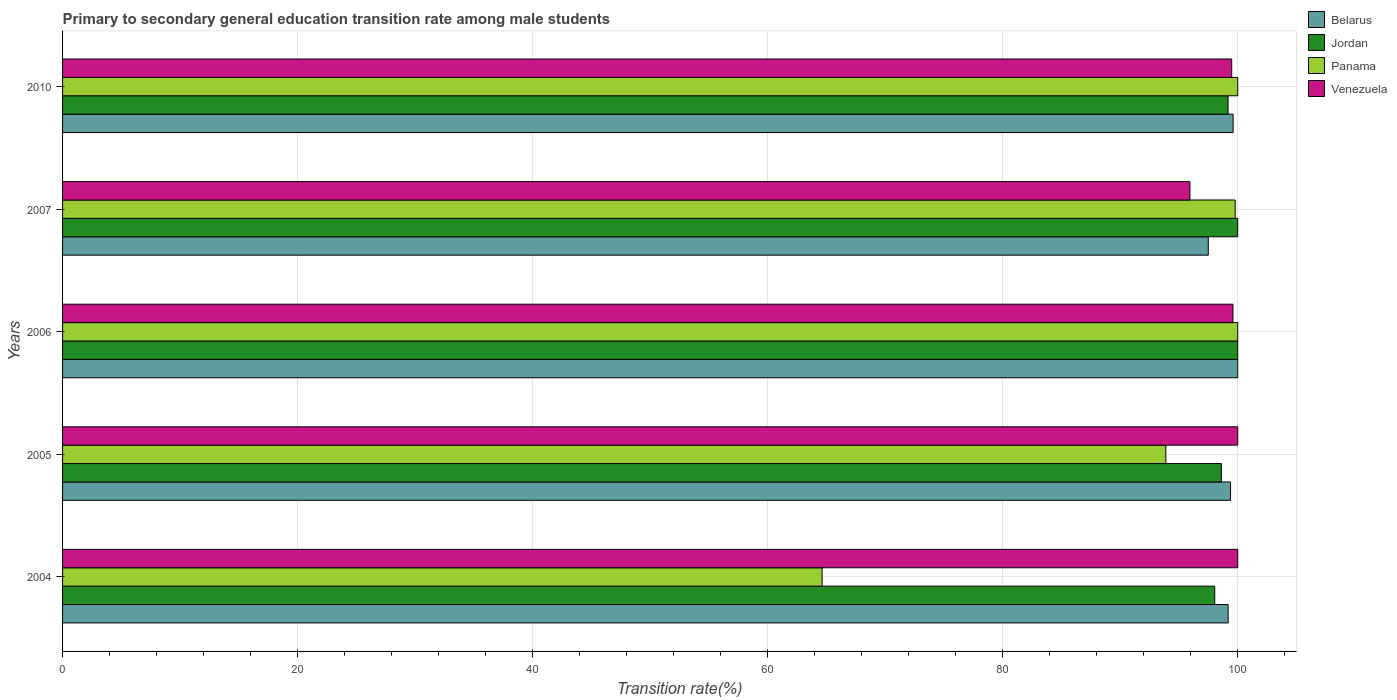How many different coloured bars are there?
Your response must be concise. 4. Are the number of bars per tick equal to the number of legend labels?
Your answer should be very brief. Yes. How many bars are there on the 3rd tick from the bottom?
Provide a short and direct response. 4. What is the label of the 4th group of bars from the top?
Provide a succinct answer. 2005. In how many cases, is the number of bars for a given year not equal to the number of legend labels?
Your response must be concise. 0. What is the transition rate in Belarus in 2004?
Make the answer very short. 99.19. Across all years, what is the minimum transition rate in Jordan?
Make the answer very short. 98.04. In which year was the transition rate in Belarus minimum?
Ensure brevity in your answer.  2007. What is the total transition rate in Panama in the graph?
Offer a terse response. 458.3. What is the difference between the transition rate in Panama in 2004 and that in 2010?
Make the answer very short. -35.37. What is the difference between the transition rate in Jordan in 2004 and the transition rate in Panama in 2006?
Your answer should be very brief. -1.96. What is the average transition rate in Venezuela per year?
Give a very brief answer. 99. In the year 2007, what is the difference between the transition rate in Panama and transition rate in Belarus?
Make the answer very short. 2.29. What is the ratio of the transition rate in Jordan in 2004 to that in 2005?
Ensure brevity in your answer.  0.99. Is the difference between the transition rate in Panama in 2004 and 2006 greater than the difference between the transition rate in Belarus in 2004 and 2006?
Provide a short and direct response. No. What is the difference between the highest and the lowest transition rate in Venezuela?
Offer a terse response. 4.07. Is the sum of the transition rate in Jordan in 2006 and 2007 greater than the maximum transition rate in Panama across all years?
Give a very brief answer. Yes. What does the 4th bar from the top in 2006 represents?
Give a very brief answer. Belarus. What does the 1st bar from the bottom in 2007 represents?
Your answer should be very brief. Belarus. Is it the case that in every year, the sum of the transition rate in Jordan and transition rate in Panama is greater than the transition rate in Venezuela?
Give a very brief answer. Yes. How many bars are there?
Offer a terse response. 20. How many years are there in the graph?
Your answer should be very brief. 5. What is the difference between two consecutive major ticks on the X-axis?
Ensure brevity in your answer.  20. Does the graph contain any zero values?
Make the answer very short. No. How many legend labels are there?
Your answer should be very brief. 4. What is the title of the graph?
Offer a terse response. Primary to secondary general education transition rate among male students. What is the label or title of the X-axis?
Provide a short and direct response. Transition rate(%). What is the label or title of the Y-axis?
Keep it short and to the point. Years. What is the Transition rate(%) of Belarus in 2004?
Provide a short and direct response. 99.19. What is the Transition rate(%) of Jordan in 2004?
Make the answer very short. 98.04. What is the Transition rate(%) in Panama in 2004?
Provide a succinct answer. 64.63. What is the Transition rate(%) of Belarus in 2005?
Make the answer very short. 99.39. What is the Transition rate(%) of Jordan in 2005?
Your answer should be compact. 98.61. What is the Transition rate(%) of Panama in 2005?
Offer a very short reply. 93.88. What is the Transition rate(%) of Venezuela in 2006?
Offer a very short reply. 99.59. What is the Transition rate(%) in Belarus in 2007?
Your answer should be compact. 97.49. What is the Transition rate(%) in Panama in 2007?
Offer a very short reply. 99.79. What is the Transition rate(%) of Venezuela in 2007?
Provide a succinct answer. 95.93. What is the Transition rate(%) in Belarus in 2010?
Your response must be concise. 99.61. What is the Transition rate(%) in Jordan in 2010?
Make the answer very short. 99.18. What is the Transition rate(%) of Venezuela in 2010?
Provide a succinct answer. 99.49. Across all years, what is the maximum Transition rate(%) in Venezuela?
Ensure brevity in your answer.  100. Across all years, what is the minimum Transition rate(%) in Belarus?
Make the answer very short. 97.49. Across all years, what is the minimum Transition rate(%) of Jordan?
Offer a terse response. 98.04. Across all years, what is the minimum Transition rate(%) in Panama?
Ensure brevity in your answer.  64.63. Across all years, what is the minimum Transition rate(%) in Venezuela?
Ensure brevity in your answer.  95.93. What is the total Transition rate(%) in Belarus in the graph?
Keep it short and to the point. 495.68. What is the total Transition rate(%) of Jordan in the graph?
Your response must be concise. 495.83. What is the total Transition rate(%) in Panama in the graph?
Your response must be concise. 458.3. What is the total Transition rate(%) in Venezuela in the graph?
Your answer should be very brief. 495.01. What is the difference between the Transition rate(%) of Belarus in 2004 and that in 2005?
Provide a succinct answer. -0.2. What is the difference between the Transition rate(%) in Jordan in 2004 and that in 2005?
Ensure brevity in your answer.  -0.57. What is the difference between the Transition rate(%) in Panama in 2004 and that in 2005?
Ensure brevity in your answer.  -29.25. What is the difference between the Transition rate(%) in Venezuela in 2004 and that in 2005?
Provide a succinct answer. 0. What is the difference between the Transition rate(%) in Belarus in 2004 and that in 2006?
Your answer should be very brief. -0.81. What is the difference between the Transition rate(%) in Jordan in 2004 and that in 2006?
Your answer should be compact. -1.96. What is the difference between the Transition rate(%) in Panama in 2004 and that in 2006?
Keep it short and to the point. -35.37. What is the difference between the Transition rate(%) in Venezuela in 2004 and that in 2006?
Your answer should be compact. 0.41. What is the difference between the Transition rate(%) in Belarus in 2004 and that in 2007?
Give a very brief answer. 1.69. What is the difference between the Transition rate(%) in Jordan in 2004 and that in 2007?
Offer a terse response. -1.96. What is the difference between the Transition rate(%) in Panama in 2004 and that in 2007?
Give a very brief answer. -35.15. What is the difference between the Transition rate(%) in Venezuela in 2004 and that in 2007?
Keep it short and to the point. 4.07. What is the difference between the Transition rate(%) in Belarus in 2004 and that in 2010?
Offer a very short reply. -0.42. What is the difference between the Transition rate(%) in Jordan in 2004 and that in 2010?
Offer a terse response. -1.13. What is the difference between the Transition rate(%) of Panama in 2004 and that in 2010?
Your answer should be compact. -35.37. What is the difference between the Transition rate(%) of Venezuela in 2004 and that in 2010?
Ensure brevity in your answer.  0.51. What is the difference between the Transition rate(%) in Belarus in 2005 and that in 2006?
Offer a terse response. -0.61. What is the difference between the Transition rate(%) in Jordan in 2005 and that in 2006?
Your response must be concise. -1.39. What is the difference between the Transition rate(%) of Panama in 2005 and that in 2006?
Your response must be concise. -6.12. What is the difference between the Transition rate(%) of Venezuela in 2005 and that in 2006?
Your answer should be very brief. 0.41. What is the difference between the Transition rate(%) of Belarus in 2005 and that in 2007?
Provide a succinct answer. 1.9. What is the difference between the Transition rate(%) in Jordan in 2005 and that in 2007?
Offer a very short reply. -1.39. What is the difference between the Transition rate(%) in Panama in 2005 and that in 2007?
Provide a succinct answer. -5.91. What is the difference between the Transition rate(%) in Venezuela in 2005 and that in 2007?
Give a very brief answer. 4.07. What is the difference between the Transition rate(%) in Belarus in 2005 and that in 2010?
Provide a short and direct response. -0.22. What is the difference between the Transition rate(%) of Jordan in 2005 and that in 2010?
Ensure brevity in your answer.  -0.57. What is the difference between the Transition rate(%) of Panama in 2005 and that in 2010?
Your response must be concise. -6.12. What is the difference between the Transition rate(%) of Venezuela in 2005 and that in 2010?
Your answer should be compact. 0.51. What is the difference between the Transition rate(%) of Belarus in 2006 and that in 2007?
Make the answer very short. 2.51. What is the difference between the Transition rate(%) in Jordan in 2006 and that in 2007?
Provide a short and direct response. 0. What is the difference between the Transition rate(%) in Panama in 2006 and that in 2007?
Offer a very short reply. 0.21. What is the difference between the Transition rate(%) of Venezuela in 2006 and that in 2007?
Keep it short and to the point. 3.66. What is the difference between the Transition rate(%) of Belarus in 2006 and that in 2010?
Provide a succinct answer. 0.39. What is the difference between the Transition rate(%) of Jordan in 2006 and that in 2010?
Ensure brevity in your answer.  0.82. What is the difference between the Transition rate(%) in Panama in 2006 and that in 2010?
Your response must be concise. 0. What is the difference between the Transition rate(%) of Venezuela in 2006 and that in 2010?
Provide a succinct answer. 0.1. What is the difference between the Transition rate(%) in Belarus in 2007 and that in 2010?
Give a very brief answer. -2.11. What is the difference between the Transition rate(%) in Jordan in 2007 and that in 2010?
Provide a short and direct response. 0.82. What is the difference between the Transition rate(%) in Panama in 2007 and that in 2010?
Offer a very short reply. -0.21. What is the difference between the Transition rate(%) of Venezuela in 2007 and that in 2010?
Make the answer very short. -3.56. What is the difference between the Transition rate(%) in Belarus in 2004 and the Transition rate(%) in Jordan in 2005?
Offer a very short reply. 0.58. What is the difference between the Transition rate(%) of Belarus in 2004 and the Transition rate(%) of Panama in 2005?
Offer a terse response. 5.31. What is the difference between the Transition rate(%) of Belarus in 2004 and the Transition rate(%) of Venezuela in 2005?
Provide a short and direct response. -0.81. What is the difference between the Transition rate(%) in Jordan in 2004 and the Transition rate(%) in Panama in 2005?
Offer a very short reply. 4.16. What is the difference between the Transition rate(%) in Jordan in 2004 and the Transition rate(%) in Venezuela in 2005?
Make the answer very short. -1.96. What is the difference between the Transition rate(%) of Panama in 2004 and the Transition rate(%) of Venezuela in 2005?
Make the answer very short. -35.37. What is the difference between the Transition rate(%) in Belarus in 2004 and the Transition rate(%) in Jordan in 2006?
Keep it short and to the point. -0.81. What is the difference between the Transition rate(%) of Belarus in 2004 and the Transition rate(%) of Panama in 2006?
Provide a short and direct response. -0.81. What is the difference between the Transition rate(%) in Belarus in 2004 and the Transition rate(%) in Venezuela in 2006?
Offer a very short reply. -0.41. What is the difference between the Transition rate(%) of Jordan in 2004 and the Transition rate(%) of Panama in 2006?
Keep it short and to the point. -1.96. What is the difference between the Transition rate(%) of Jordan in 2004 and the Transition rate(%) of Venezuela in 2006?
Your answer should be very brief. -1.55. What is the difference between the Transition rate(%) of Panama in 2004 and the Transition rate(%) of Venezuela in 2006?
Give a very brief answer. -34.96. What is the difference between the Transition rate(%) in Belarus in 2004 and the Transition rate(%) in Jordan in 2007?
Your response must be concise. -0.81. What is the difference between the Transition rate(%) of Belarus in 2004 and the Transition rate(%) of Panama in 2007?
Provide a short and direct response. -0.6. What is the difference between the Transition rate(%) of Belarus in 2004 and the Transition rate(%) of Venezuela in 2007?
Your answer should be very brief. 3.25. What is the difference between the Transition rate(%) in Jordan in 2004 and the Transition rate(%) in Panama in 2007?
Ensure brevity in your answer.  -1.74. What is the difference between the Transition rate(%) in Jordan in 2004 and the Transition rate(%) in Venezuela in 2007?
Your answer should be very brief. 2.11. What is the difference between the Transition rate(%) in Panama in 2004 and the Transition rate(%) in Venezuela in 2007?
Make the answer very short. -31.3. What is the difference between the Transition rate(%) in Belarus in 2004 and the Transition rate(%) in Jordan in 2010?
Offer a very short reply. 0.01. What is the difference between the Transition rate(%) in Belarus in 2004 and the Transition rate(%) in Panama in 2010?
Give a very brief answer. -0.81. What is the difference between the Transition rate(%) of Belarus in 2004 and the Transition rate(%) of Venezuela in 2010?
Provide a succinct answer. -0.3. What is the difference between the Transition rate(%) in Jordan in 2004 and the Transition rate(%) in Panama in 2010?
Your answer should be very brief. -1.96. What is the difference between the Transition rate(%) in Jordan in 2004 and the Transition rate(%) in Venezuela in 2010?
Keep it short and to the point. -1.44. What is the difference between the Transition rate(%) of Panama in 2004 and the Transition rate(%) of Venezuela in 2010?
Your answer should be compact. -34.85. What is the difference between the Transition rate(%) in Belarus in 2005 and the Transition rate(%) in Jordan in 2006?
Your answer should be very brief. -0.61. What is the difference between the Transition rate(%) in Belarus in 2005 and the Transition rate(%) in Panama in 2006?
Keep it short and to the point. -0.61. What is the difference between the Transition rate(%) of Belarus in 2005 and the Transition rate(%) of Venezuela in 2006?
Provide a succinct answer. -0.2. What is the difference between the Transition rate(%) of Jordan in 2005 and the Transition rate(%) of Panama in 2006?
Keep it short and to the point. -1.39. What is the difference between the Transition rate(%) in Jordan in 2005 and the Transition rate(%) in Venezuela in 2006?
Ensure brevity in your answer.  -0.98. What is the difference between the Transition rate(%) of Panama in 2005 and the Transition rate(%) of Venezuela in 2006?
Make the answer very short. -5.71. What is the difference between the Transition rate(%) in Belarus in 2005 and the Transition rate(%) in Jordan in 2007?
Ensure brevity in your answer.  -0.61. What is the difference between the Transition rate(%) in Belarus in 2005 and the Transition rate(%) in Panama in 2007?
Offer a terse response. -0.4. What is the difference between the Transition rate(%) of Belarus in 2005 and the Transition rate(%) of Venezuela in 2007?
Make the answer very short. 3.46. What is the difference between the Transition rate(%) of Jordan in 2005 and the Transition rate(%) of Panama in 2007?
Offer a very short reply. -1.18. What is the difference between the Transition rate(%) in Jordan in 2005 and the Transition rate(%) in Venezuela in 2007?
Make the answer very short. 2.68. What is the difference between the Transition rate(%) of Panama in 2005 and the Transition rate(%) of Venezuela in 2007?
Keep it short and to the point. -2.05. What is the difference between the Transition rate(%) of Belarus in 2005 and the Transition rate(%) of Jordan in 2010?
Offer a very short reply. 0.21. What is the difference between the Transition rate(%) in Belarus in 2005 and the Transition rate(%) in Panama in 2010?
Your response must be concise. -0.61. What is the difference between the Transition rate(%) in Belarus in 2005 and the Transition rate(%) in Venezuela in 2010?
Your answer should be compact. -0.1. What is the difference between the Transition rate(%) in Jordan in 2005 and the Transition rate(%) in Panama in 2010?
Make the answer very short. -1.39. What is the difference between the Transition rate(%) of Jordan in 2005 and the Transition rate(%) of Venezuela in 2010?
Offer a terse response. -0.88. What is the difference between the Transition rate(%) of Panama in 2005 and the Transition rate(%) of Venezuela in 2010?
Make the answer very short. -5.61. What is the difference between the Transition rate(%) of Belarus in 2006 and the Transition rate(%) of Jordan in 2007?
Your answer should be very brief. 0. What is the difference between the Transition rate(%) in Belarus in 2006 and the Transition rate(%) in Panama in 2007?
Make the answer very short. 0.21. What is the difference between the Transition rate(%) in Belarus in 2006 and the Transition rate(%) in Venezuela in 2007?
Your answer should be very brief. 4.07. What is the difference between the Transition rate(%) of Jordan in 2006 and the Transition rate(%) of Panama in 2007?
Your response must be concise. 0.21. What is the difference between the Transition rate(%) in Jordan in 2006 and the Transition rate(%) in Venezuela in 2007?
Keep it short and to the point. 4.07. What is the difference between the Transition rate(%) in Panama in 2006 and the Transition rate(%) in Venezuela in 2007?
Offer a terse response. 4.07. What is the difference between the Transition rate(%) in Belarus in 2006 and the Transition rate(%) in Jordan in 2010?
Ensure brevity in your answer.  0.82. What is the difference between the Transition rate(%) in Belarus in 2006 and the Transition rate(%) in Panama in 2010?
Provide a short and direct response. 0. What is the difference between the Transition rate(%) of Belarus in 2006 and the Transition rate(%) of Venezuela in 2010?
Ensure brevity in your answer.  0.51. What is the difference between the Transition rate(%) of Jordan in 2006 and the Transition rate(%) of Venezuela in 2010?
Your answer should be very brief. 0.51. What is the difference between the Transition rate(%) of Panama in 2006 and the Transition rate(%) of Venezuela in 2010?
Ensure brevity in your answer.  0.51. What is the difference between the Transition rate(%) in Belarus in 2007 and the Transition rate(%) in Jordan in 2010?
Offer a very short reply. -1.68. What is the difference between the Transition rate(%) in Belarus in 2007 and the Transition rate(%) in Panama in 2010?
Make the answer very short. -2.51. What is the difference between the Transition rate(%) in Belarus in 2007 and the Transition rate(%) in Venezuela in 2010?
Your answer should be very brief. -1.99. What is the difference between the Transition rate(%) of Jordan in 2007 and the Transition rate(%) of Venezuela in 2010?
Offer a very short reply. 0.51. What is the difference between the Transition rate(%) of Panama in 2007 and the Transition rate(%) of Venezuela in 2010?
Ensure brevity in your answer.  0.3. What is the average Transition rate(%) of Belarus per year?
Your answer should be very brief. 99.14. What is the average Transition rate(%) in Jordan per year?
Your response must be concise. 99.17. What is the average Transition rate(%) in Panama per year?
Provide a short and direct response. 91.66. What is the average Transition rate(%) in Venezuela per year?
Keep it short and to the point. 99. In the year 2004, what is the difference between the Transition rate(%) of Belarus and Transition rate(%) of Jordan?
Your answer should be compact. 1.14. In the year 2004, what is the difference between the Transition rate(%) of Belarus and Transition rate(%) of Panama?
Give a very brief answer. 34.55. In the year 2004, what is the difference between the Transition rate(%) in Belarus and Transition rate(%) in Venezuela?
Your answer should be compact. -0.81. In the year 2004, what is the difference between the Transition rate(%) in Jordan and Transition rate(%) in Panama?
Provide a succinct answer. 33.41. In the year 2004, what is the difference between the Transition rate(%) in Jordan and Transition rate(%) in Venezuela?
Offer a terse response. -1.96. In the year 2004, what is the difference between the Transition rate(%) in Panama and Transition rate(%) in Venezuela?
Keep it short and to the point. -35.37. In the year 2005, what is the difference between the Transition rate(%) of Belarus and Transition rate(%) of Jordan?
Your response must be concise. 0.78. In the year 2005, what is the difference between the Transition rate(%) of Belarus and Transition rate(%) of Panama?
Keep it short and to the point. 5.51. In the year 2005, what is the difference between the Transition rate(%) in Belarus and Transition rate(%) in Venezuela?
Keep it short and to the point. -0.61. In the year 2005, what is the difference between the Transition rate(%) of Jordan and Transition rate(%) of Panama?
Your response must be concise. 4.73. In the year 2005, what is the difference between the Transition rate(%) of Jordan and Transition rate(%) of Venezuela?
Ensure brevity in your answer.  -1.39. In the year 2005, what is the difference between the Transition rate(%) in Panama and Transition rate(%) in Venezuela?
Offer a very short reply. -6.12. In the year 2006, what is the difference between the Transition rate(%) in Belarus and Transition rate(%) in Jordan?
Offer a very short reply. 0. In the year 2006, what is the difference between the Transition rate(%) of Belarus and Transition rate(%) of Venezuela?
Give a very brief answer. 0.41. In the year 2006, what is the difference between the Transition rate(%) in Jordan and Transition rate(%) in Panama?
Keep it short and to the point. 0. In the year 2006, what is the difference between the Transition rate(%) of Jordan and Transition rate(%) of Venezuela?
Your answer should be compact. 0.41. In the year 2006, what is the difference between the Transition rate(%) in Panama and Transition rate(%) in Venezuela?
Keep it short and to the point. 0.41. In the year 2007, what is the difference between the Transition rate(%) of Belarus and Transition rate(%) of Jordan?
Make the answer very short. -2.51. In the year 2007, what is the difference between the Transition rate(%) in Belarus and Transition rate(%) in Panama?
Offer a terse response. -2.29. In the year 2007, what is the difference between the Transition rate(%) in Belarus and Transition rate(%) in Venezuela?
Provide a succinct answer. 1.56. In the year 2007, what is the difference between the Transition rate(%) of Jordan and Transition rate(%) of Panama?
Your response must be concise. 0.21. In the year 2007, what is the difference between the Transition rate(%) of Jordan and Transition rate(%) of Venezuela?
Ensure brevity in your answer.  4.07. In the year 2007, what is the difference between the Transition rate(%) of Panama and Transition rate(%) of Venezuela?
Offer a very short reply. 3.85. In the year 2010, what is the difference between the Transition rate(%) in Belarus and Transition rate(%) in Jordan?
Provide a short and direct response. 0.43. In the year 2010, what is the difference between the Transition rate(%) in Belarus and Transition rate(%) in Panama?
Offer a terse response. -0.39. In the year 2010, what is the difference between the Transition rate(%) of Belarus and Transition rate(%) of Venezuela?
Offer a terse response. 0.12. In the year 2010, what is the difference between the Transition rate(%) of Jordan and Transition rate(%) of Panama?
Provide a short and direct response. -0.82. In the year 2010, what is the difference between the Transition rate(%) in Jordan and Transition rate(%) in Venezuela?
Offer a very short reply. -0.31. In the year 2010, what is the difference between the Transition rate(%) in Panama and Transition rate(%) in Venezuela?
Give a very brief answer. 0.51. What is the ratio of the Transition rate(%) in Belarus in 2004 to that in 2005?
Give a very brief answer. 1. What is the ratio of the Transition rate(%) of Jordan in 2004 to that in 2005?
Your response must be concise. 0.99. What is the ratio of the Transition rate(%) of Panama in 2004 to that in 2005?
Ensure brevity in your answer.  0.69. What is the ratio of the Transition rate(%) of Venezuela in 2004 to that in 2005?
Offer a very short reply. 1. What is the ratio of the Transition rate(%) in Jordan in 2004 to that in 2006?
Your answer should be very brief. 0.98. What is the ratio of the Transition rate(%) of Panama in 2004 to that in 2006?
Provide a short and direct response. 0.65. What is the ratio of the Transition rate(%) of Belarus in 2004 to that in 2007?
Make the answer very short. 1.02. What is the ratio of the Transition rate(%) of Jordan in 2004 to that in 2007?
Your response must be concise. 0.98. What is the ratio of the Transition rate(%) in Panama in 2004 to that in 2007?
Provide a succinct answer. 0.65. What is the ratio of the Transition rate(%) of Venezuela in 2004 to that in 2007?
Offer a very short reply. 1.04. What is the ratio of the Transition rate(%) of Panama in 2004 to that in 2010?
Offer a terse response. 0.65. What is the ratio of the Transition rate(%) of Belarus in 2005 to that in 2006?
Ensure brevity in your answer.  0.99. What is the ratio of the Transition rate(%) in Jordan in 2005 to that in 2006?
Your response must be concise. 0.99. What is the ratio of the Transition rate(%) of Panama in 2005 to that in 2006?
Provide a succinct answer. 0.94. What is the ratio of the Transition rate(%) in Belarus in 2005 to that in 2007?
Ensure brevity in your answer.  1.02. What is the ratio of the Transition rate(%) of Jordan in 2005 to that in 2007?
Your answer should be compact. 0.99. What is the ratio of the Transition rate(%) of Panama in 2005 to that in 2007?
Give a very brief answer. 0.94. What is the ratio of the Transition rate(%) in Venezuela in 2005 to that in 2007?
Make the answer very short. 1.04. What is the ratio of the Transition rate(%) in Panama in 2005 to that in 2010?
Your answer should be very brief. 0.94. What is the ratio of the Transition rate(%) in Belarus in 2006 to that in 2007?
Ensure brevity in your answer.  1.03. What is the ratio of the Transition rate(%) in Jordan in 2006 to that in 2007?
Provide a short and direct response. 1. What is the ratio of the Transition rate(%) in Venezuela in 2006 to that in 2007?
Make the answer very short. 1.04. What is the ratio of the Transition rate(%) of Jordan in 2006 to that in 2010?
Offer a terse response. 1.01. What is the ratio of the Transition rate(%) in Panama in 2006 to that in 2010?
Your answer should be very brief. 1. What is the ratio of the Transition rate(%) of Belarus in 2007 to that in 2010?
Keep it short and to the point. 0.98. What is the ratio of the Transition rate(%) in Jordan in 2007 to that in 2010?
Give a very brief answer. 1.01. What is the difference between the highest and the second highest Transition rate(%) of Belarus?
Your answer should be compact. 0.39. What is the difference between the highest and the second highest Transition rate(%) in Jordan?
Your answer should be compact. 0. What is the difference between the highest and the lowest Transition rate(%) in Belarus?
Your answer should be very brief. 2.51. What is the difference between the highest and the lowest Transition rate(%) of Jordan?
Provide a short and direct response. 1.96. What is the difference between the highest and the lowest Transition rate(%) in Panama?
Provide a short and direct response. 35.37. What is the difference between the highest and the lowest Transition rate(%) of Venezuela?
Make the answer very short. 4.07. 